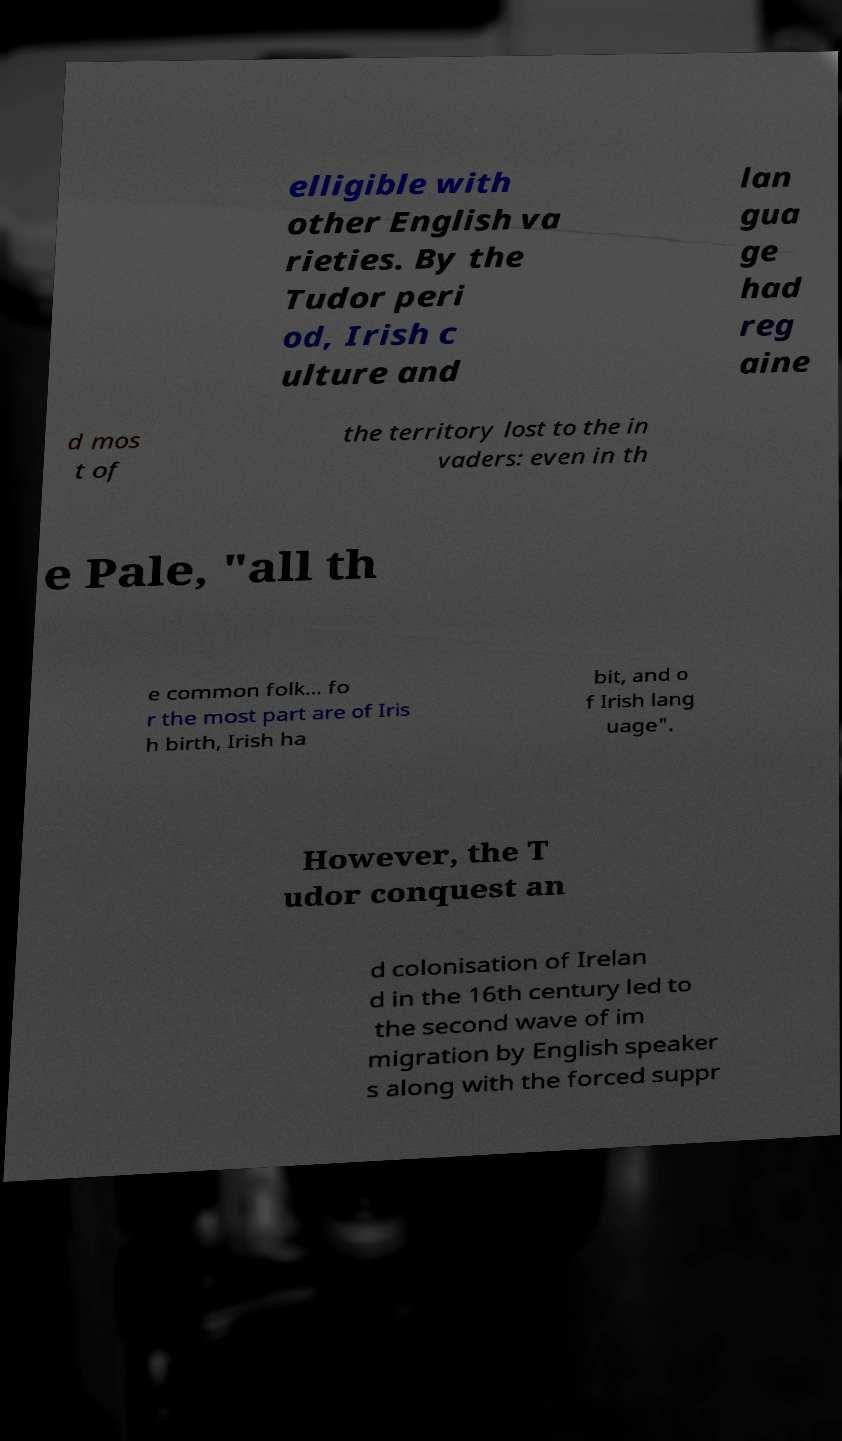Could you assist in decoding the text presented in this image and type it out clearly? elligible with other English va rieties. By the Tudor peri od, Irish c ulture and lan gua ge had reg aine d mos t of the territory lost to the in vaders: even in th e Pale, "all th e common folk… fo r the most part are of Iris h birth, Irish ha bit, and o f Irish lang uage". However, the T udor conquest an d colonisation of Irelan d in the 16th century led to the second wave of im migration by English speaker s along with the forced suppr 